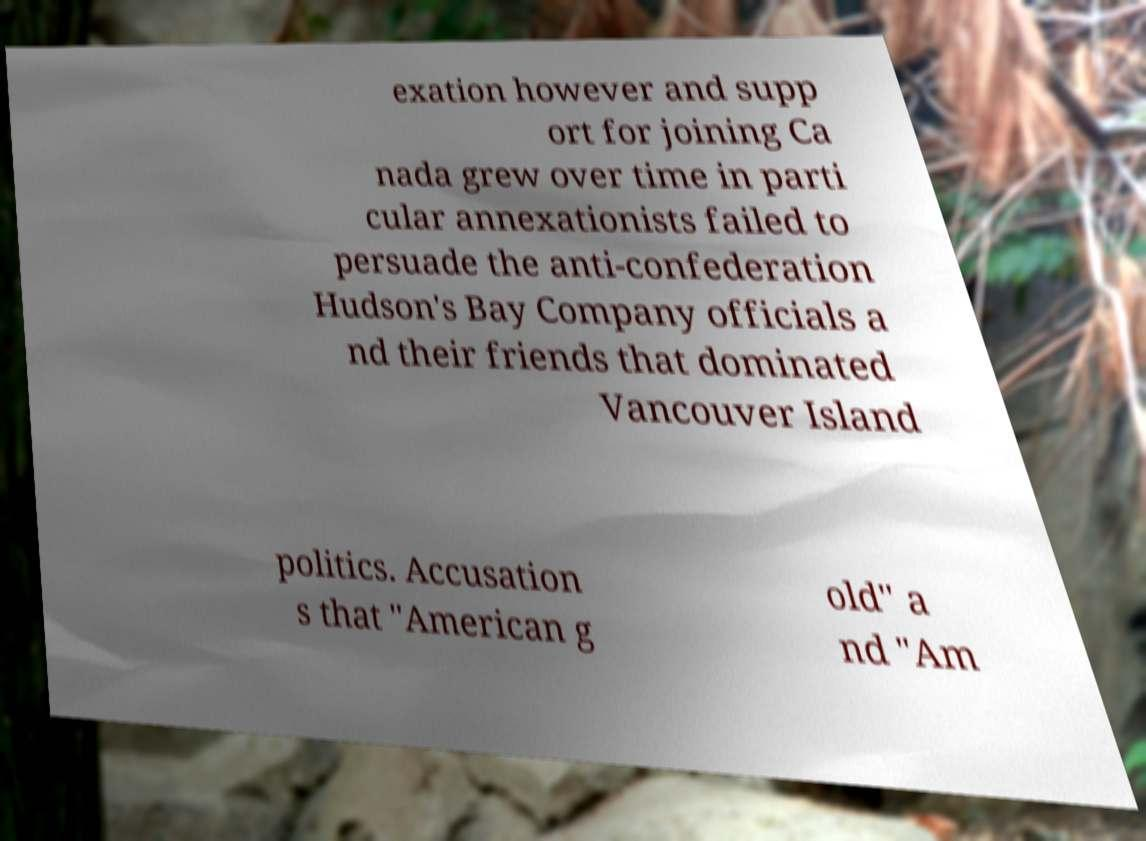What messages or text are displayed in this image? I need them in a readable, typed format. exation however and supp ort for joining Ca nada grew over time in parti cular annexationists failed to persuade the anti-confederation Hudson's Bay Company officials a nd their friends that dominated Vancouver Island politics. Accusation s that "American g old" a nd "Am 